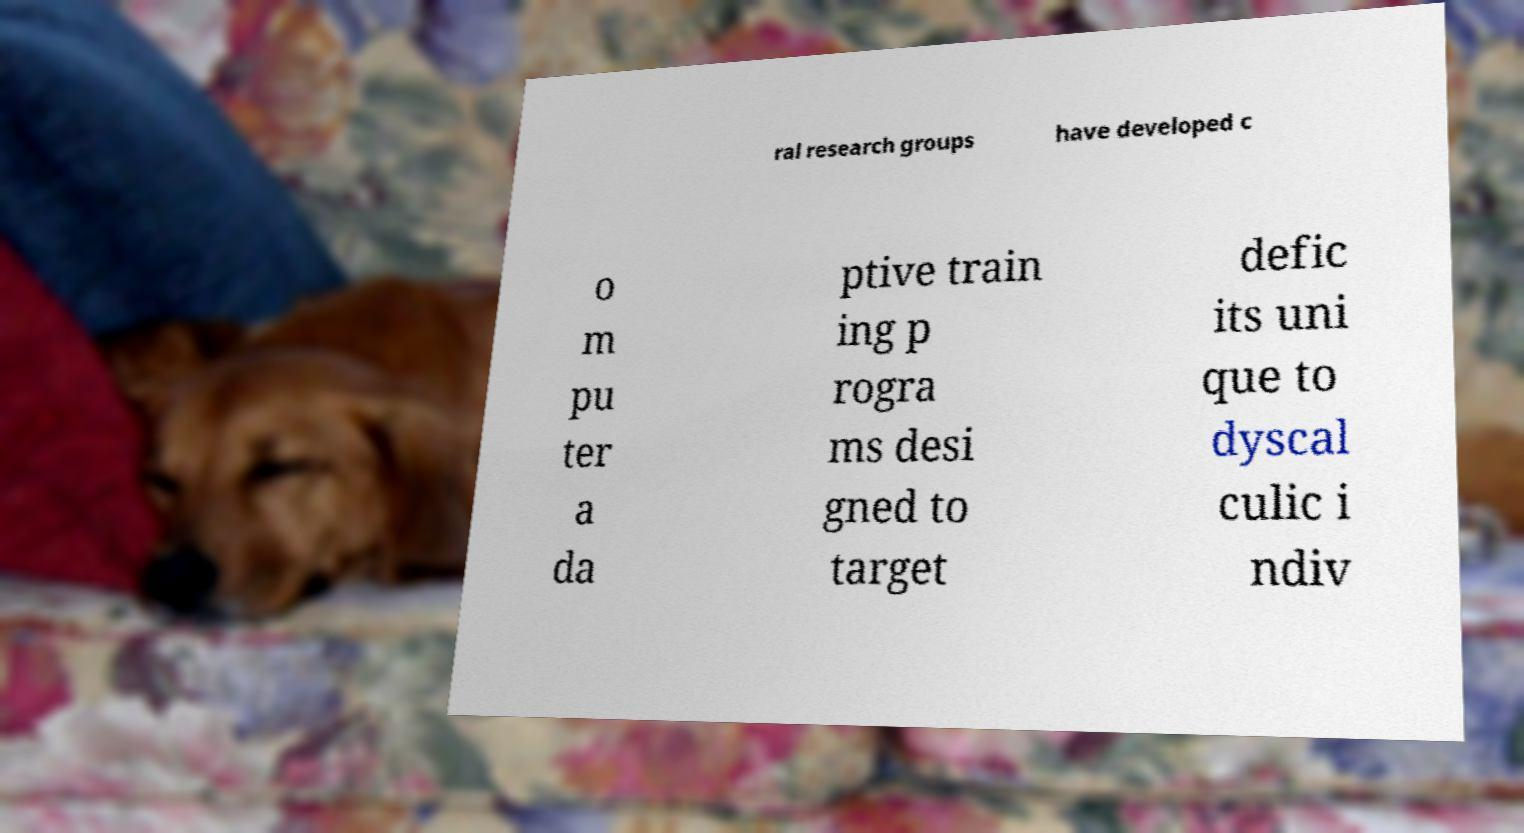Could you assist in decoding the text presented in this image and type it out clearly? ral research groups have developed c o m pu ter a da ptive train ing p rogra ms desi gned to target defic its uni que to dyscal culic i ndiv 